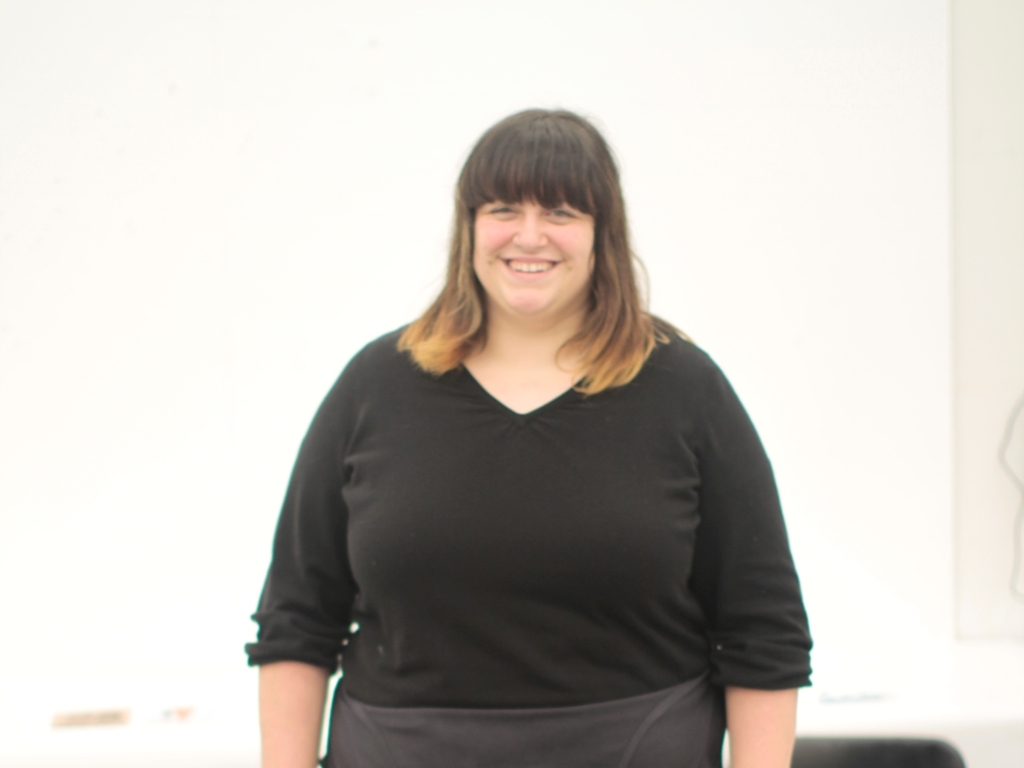What type of clothing is the woman in the picture wearing? The woman in the picture is wearing a simple, elegant black outfit with a v-neck top and appears to be dressed comfortably, in clothes that might be suitable for a casual or semi-formal occasion. 